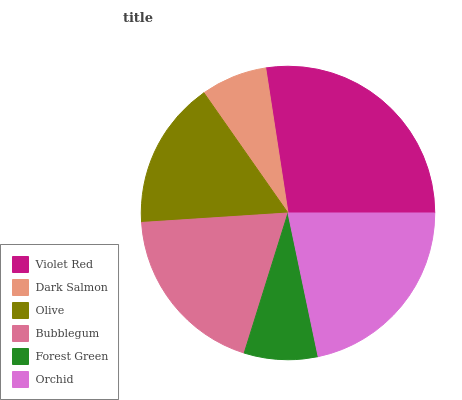Is Dark Salmon the minimum?
Answer yes or no. Yes. Is Violet Red the maximum?
Answer yes or no. Yes. Is Olive the minimum?
Answer yes or no. No. Is Olive the maximum?
Answer yes or no. No. Is Olive greater than Dark Salmon?
Answer yes or no. Yes. Is Dark Salmon less than Olive?
Answer yes or no. Yes. Is Dark Salmon greater than Olive?
Answer yes or no. No. Is Olive less than Dark Salmon?
Answer yes or no. No. Is Bubblegum the high median?
Answer yes or no. Yes. Is Olive the low median?
Answer yes or no. Yes. Is Olive the high median?
Answer yes or no. No. Is Dark Salmon the low median?
Answer yes or no. No. 